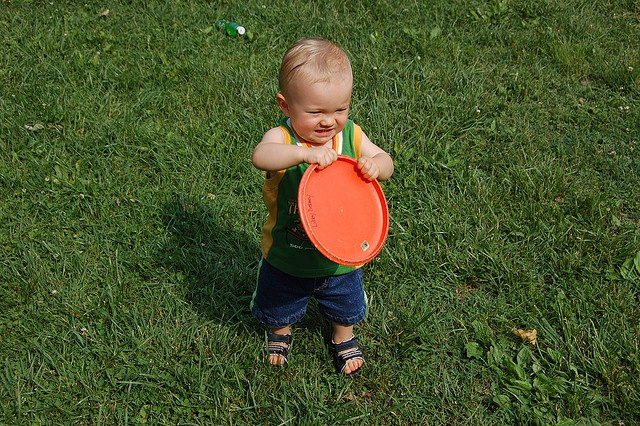Describe the objects in this image and their specific colors. I can see people in darkgreen, black, tan, and gray tones and frisbee in darkgreen, salmon, and red tones in this image. 